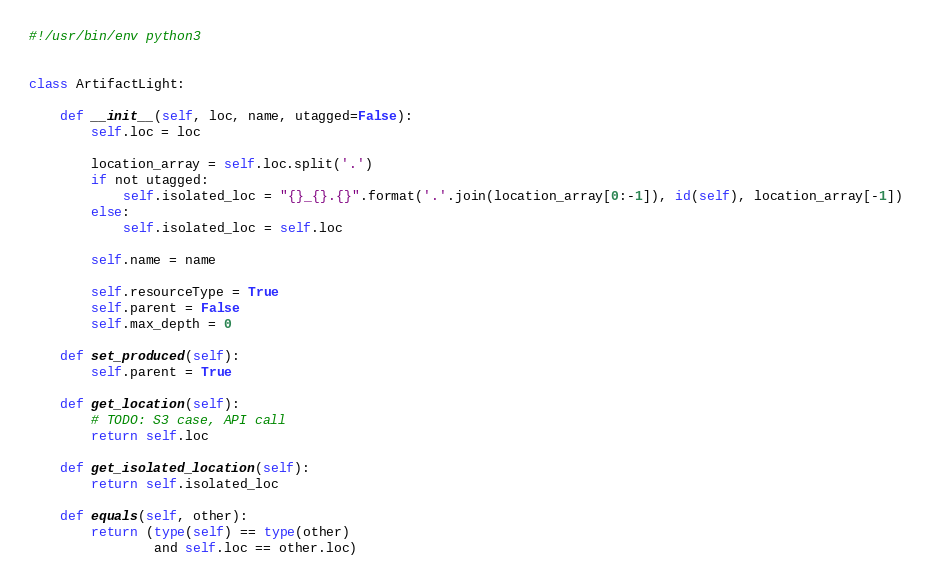Convert code to text. <code><loc_0><loc_0><loc_500><loc_500><_Python_>#!/usr/bin/env python3


class ArtifactLight:

    def __init__(self, loc, name, utagged=False):
        self.loc = loc

        location_array = self.loc.split('.')
        if not utagged:
            self.isolated_loc = "{}_{}.{}".format('.'.join(location_array[0:-1]), id(self), location_array[-1])
        else:
            self.isolated_loc = self.loc

        self.name = name

        self.resourceType = True
        self.parent = False
        self.max_depth = 0

    def set_produced(self):
        self.parent = True

    def get_location(self):
        # TODO: S3 case, API call
        return self.loc

    def get_isolated_location(self):
        return self.isolated_loc

    def equals(self, other):
        return (type(self) == type(other)
                and self.loc == other.loc)
</code> 